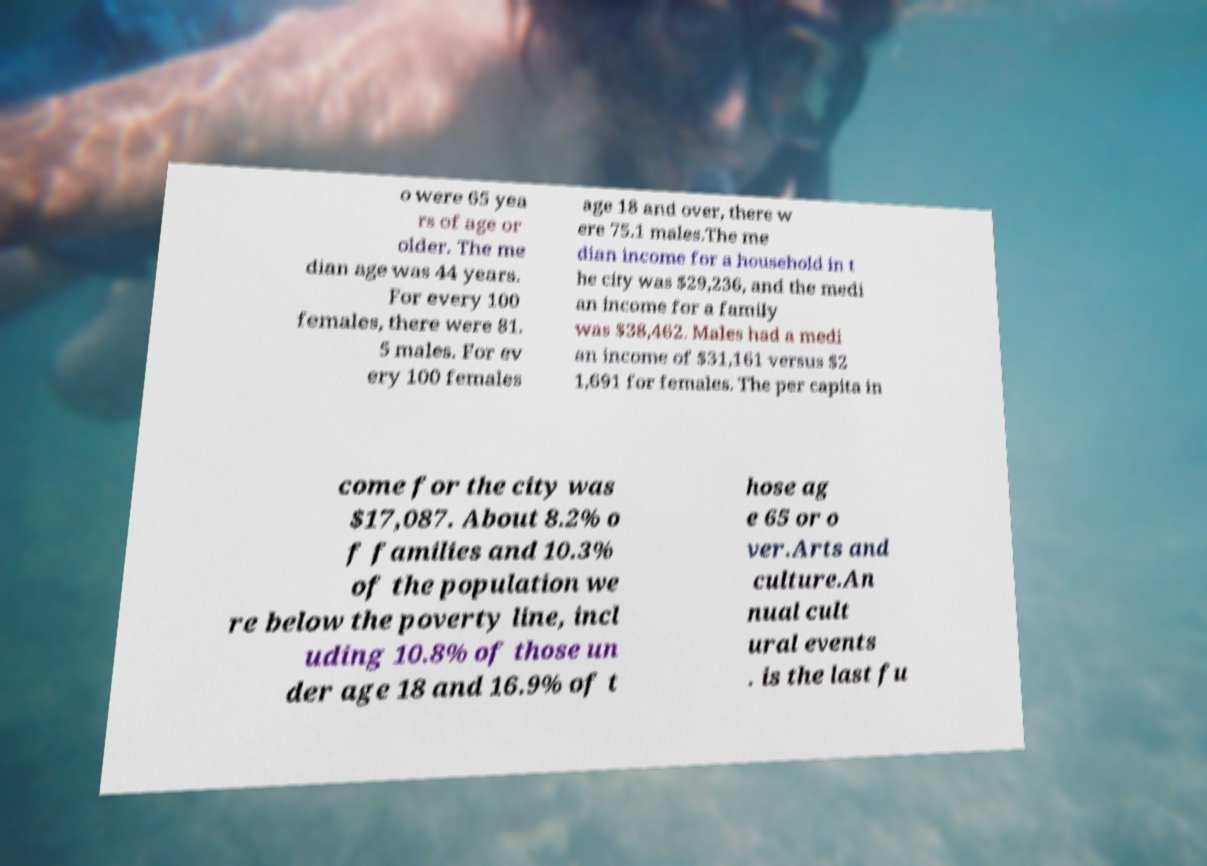I need the written content from this picture converted into text. Can you do that? o were 65 yea rs of age or older. The me dian age was 44 years. For every 100 females, there were 81. 5 males. For ev ery 100 females age 18 and over, there w ere 75.1 males.The me dian income for a household in t he city was $29,236, and the medi an income for a family was $38,462. Males had a medi an income of $31,161 versus $2 1,691 for females. The per capita in come for the city was $17,087. About 8.2% o f families and 10.3% of the population we re below the poverty line, incl uding 10.8% of those un der age 18 and 16.9% of t hose ag e 65 or o ver.Arts and culture.An nual cult ural events . is the last fu 